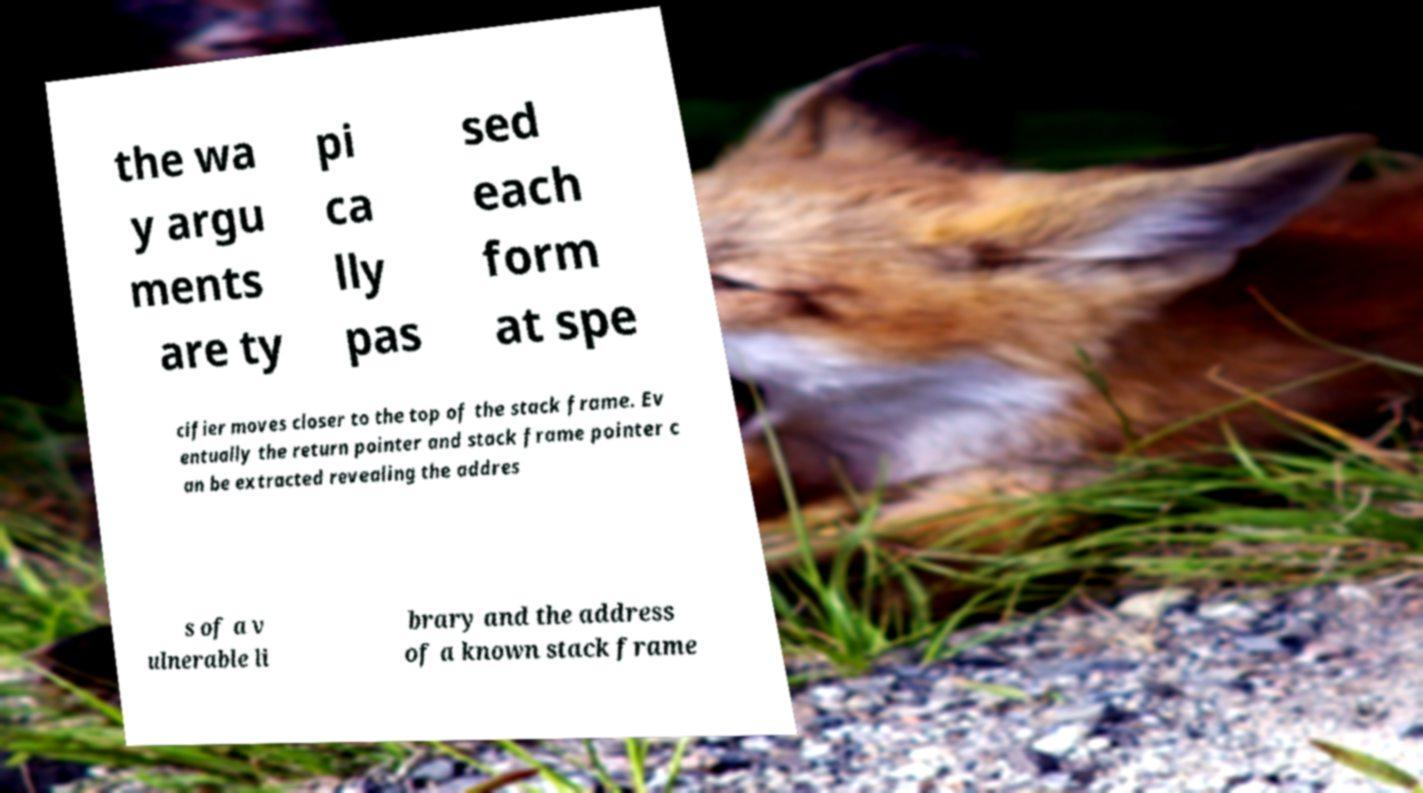Can you accurately transcribe the text from the provided image for me? the wa y argu ments are ty pi ca lly pas sed each form at spe cifier moves closer to the top of the stack frame. Ev entually the return pointer and stack frame pointer c an be extracted revealing the addres s of a v ulnerable li brary and the address of a known stack frame 